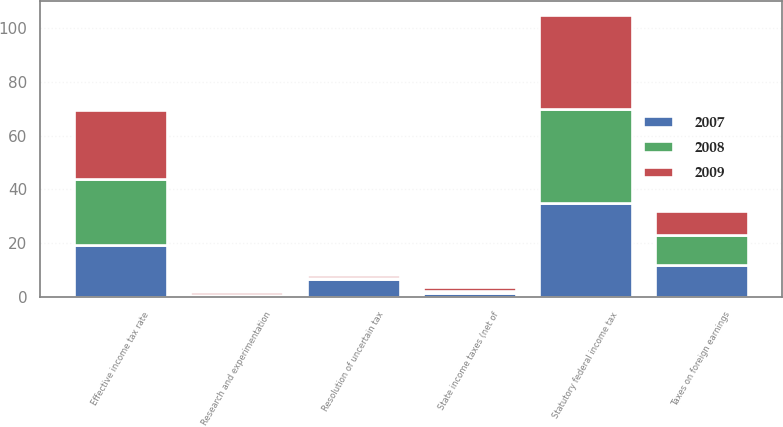Convert chart to OTSL. <chart><loc_0><loc_0><loc_500><loc_500><stacked_bar_chart><ecel><fcel>Statutory federal income tax<fcel>State income taxes (net of<fcel>Taxes on foreign earnings<fcel>Resolution of uncertain tax<fcel>Research and experimentation<fcel>Effective income tax rate<nl><fcel>2007<fcel>35<fcel>1.6<fcel>11.8<fcel>6.8<fcel>0.7<fcel>19.2<nl><fcel>2008<fcel>35<fcel>0.8<fcel>11.1<fcel>0.1<fcel>0.1<fcel>24.7<nl><fcel>2009<fcel>35<fcel>1.2<fcel>9.2<fcel>1.4<fcel>1.1<fcel>25.8<nl></chart> 